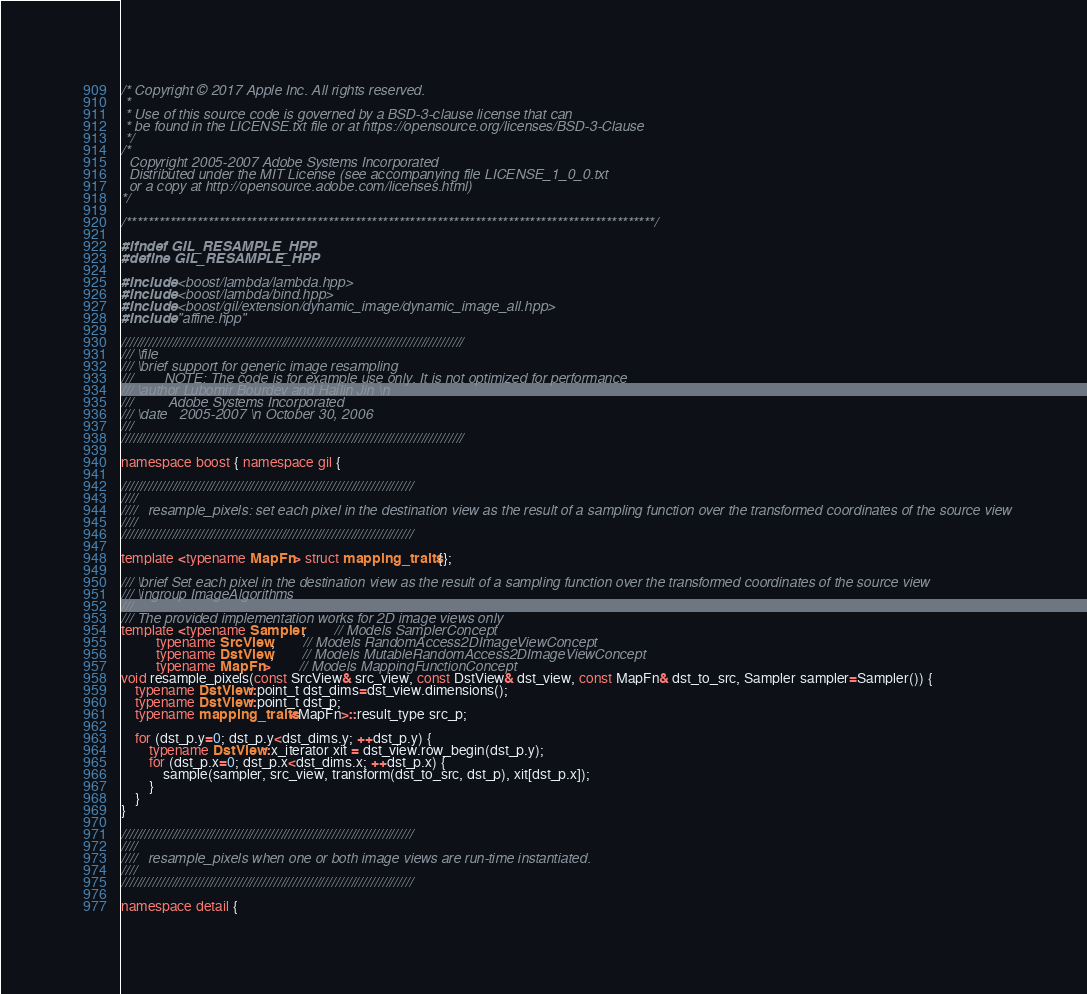Convert code to text. <code><loc_0><loc_0><loc_500><loc_500><_C++_>/* Copyright © 2017 Apple Inc. All rights reserved.
 *
 * Use of this source code is governed by a BSD-3-clause license that can
 * be found in the LICENSE.txt file or at https://opensource.org/licenses/BSD-3-Clause
 */
/*
  Copyright 2005-2007 Adobe Systems Incorporated
  Distributed under the MIT License (see accompanying file LICENSE_1_0_0.txt
  or a copy at http://opensource.adobe.com/licenses.html)
*/

/*************************************************************************************************/

#ifndef GIL_RESAMPLE_HPP
#define GIL_RESAMPLE_HPP

#include <boost/lambda/lambda.hpp>
#include <boost/lambda/bind.hpp>
#include <boost/gil/extension/dynamic_image/dynamic_image_all.hpp>
#include "affine.hpp"

////////////////////////////////////////////////////////////////////////////////////////
/// \file
/// \brief support for generic image resampling
///        NOTE: The code is for example use only. It is not optimized for performance
/// \author Lubomir Bourdev and Hailin Jin \n
///         Adobe Systems Incorporated
/// \date   2005-2007 \n October 30, 2006
///
////////////////////////////////////////////////////////////////////////////////////////

namespace boost { namespace gil {

///////////////////////////////////////////////////////////////////////////
////
////   resample_pixels: set each pixel in the destination view as the result of a sampling function over the transformed coordinates of the source view
////
///////////////////////////////////////////////////////////////////////////

template <typename MapFn> struct mapping_traits {};

/// \brief Set each pixel in the destination view as the result of a sampling function over the transformed coordinates of the source view
/// \ingroup ImageAlgorithms
///
/// The provided implementation works for 2D image views only
template <typename Sampler,        // Models SamplerConcept
          typename SrcView,        // Models RandomAccess2DImageViewConcept
          typename DstView,        // Models MutableRandomAccess2DImageViewConcept
          typename MapFn>        // Models MappingFunctionConcept
void resample_pixels(const SrcView& src_view, const DstView& dst_view, const MapFn& dst_to_src, Sampler sampler=Sampler()) {
    typename DstView::point_t dst_dims=dst_view.dimensions();
    typename DstView::point_t dst_p;
    typename mapping_traits<MapFn>::result_type src_p;

    for (dst_p.y=0; dst_p.y<dst_dims.y; ++dst_p.y) {
        typename DstView::x_iterator xit = dst_view.row_begin(dst_p.y);
        for (dst_p.x=0; dst_p.x<dst_dims.x; ++dst_p.x) {
            sample(sampler, src_view, transform(dst_to_src, dst_p), xit[dst_p.x]);
        }
    }
}

///////////////////////////////////////////////////////////////////////////
////
////   resample_pixels when one or both image views are run-time instantiated.
////
///////////////////////////////////////////////////////////////////////////

namespace detail {</code> 